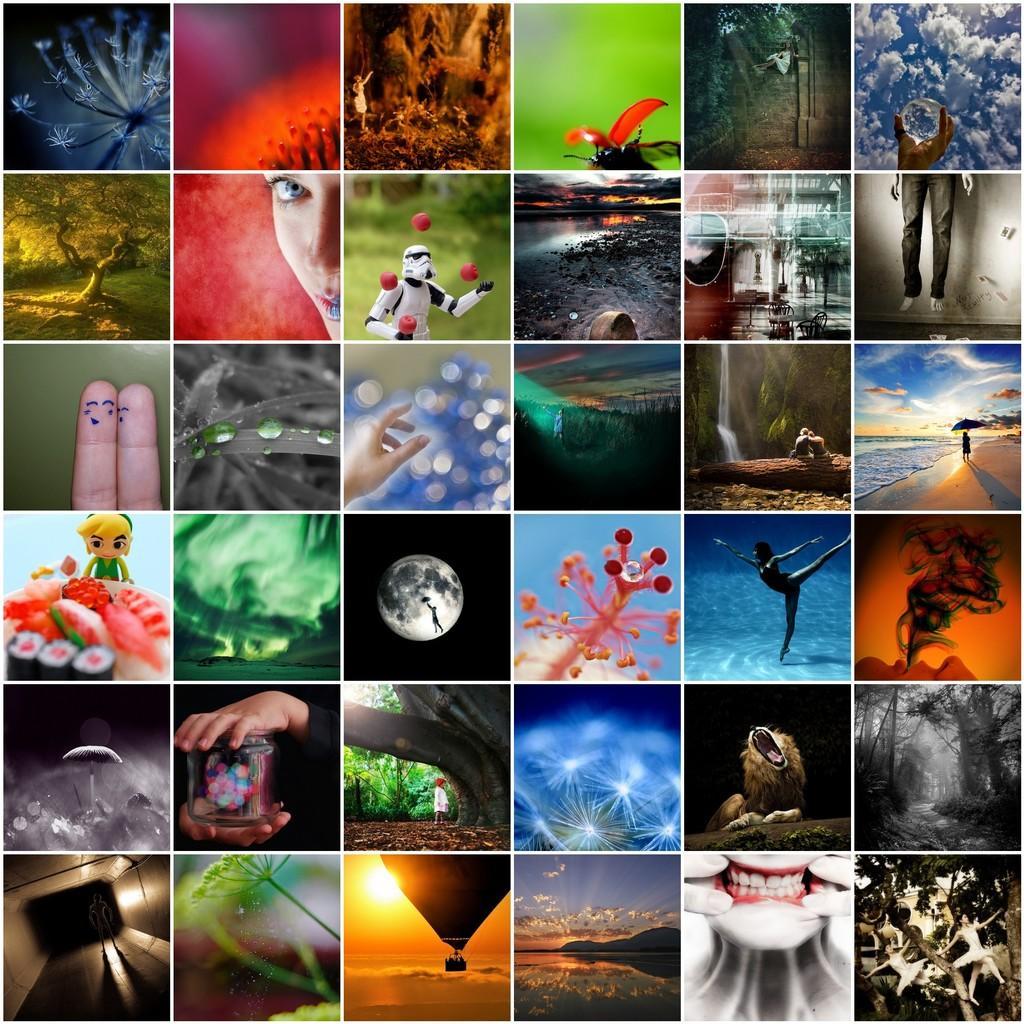In one or two sentences, can you explain what this image depicts? This is an image with collage. In this image we can see different types of pictures such as the hand of a person holding a jar, a hot balloon and the sun, the face of a person, some trees, a person walking beside a water body, the stem of a plant and the sky. 